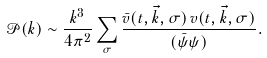<formula> <loc_0><loc_0><loc_500><loc_500>\mathcal { P } ( k ) \sim \frac { k ^ { 3 } } { 4 \pi ^ { 2 } } \sum _ { \sigma } \frac { \bar { v } ( t , \vec { k } , \sigma ) \, v ( t , \vec { k } , \sigma ) } { ( \bar { \psi } \psi ) } .</formula> 